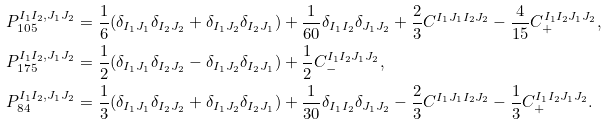<formula> <loc_0><loc_0><loc_500><loc_500>& P _ { 1 0 5 } ^ { I _ { 1 } I _ { 2 } , J _ { 1 } J _ { 2 } } = \frac { 1 } { 6 } ( \delta _ { I _ { 1 } J _ { 1 } } \delta _ { I _ { 2 } J _ { 2 } } + \delta _ { I _ { 1 } J _ { 2 } } \delta _ { I _ { 2 } J _ { 1 } } ) + \frac { 1 } { 6 0 } \delta _ { I _ { 1 } I _ { 2 } } \delta _ { J _ { 1 } J _ { 2 } } + \frac { 2 } { 3 } C ^ { I _ { 1 } J _ { 1 } I _ { 2 } J _ { 2 } } - \frac { 4 } { 1 5 } C _ { + } ^ { I _ { 1 } I _ { 2 } J _ { 1 } J _ { 2 } } , \\ & P _ { 1 7 5 } ^ { I _ { 1 } I _ { 2 } , J _ { 1 } J _ { 2 } } = \frac { 1 } { 2 } ( \delta _ { I _ { 1 } J _ { 1 } } \delta _ { I _ { 2 } J _ { 2 } } - \delta _ { I _ { 1 } J _ { 2 } } \delta _ { I _ { 2 } J _ { 1 } } ) + \frac { 1 } { 2 } C _ { - } ^ { I _ { 1 } I _ { 2 } J _ { 1 } J _ { 2 } } , \\ & P _ { 8 4 } ^ { I _ { 1 } I _ { 2 } , J _ { 1 } J _ { 2 } } = \frac { 1 } { 3 } ( \delta _ { I _ { 1 } J _ { 1 } } \delta _ { I _ { 2 } J _ { 2 } } + \delta _ { I _ { 1 } J _ { 2 } } \delta _ { I _ { 2 } J _ { 1 } } ) + \frac { 1 } { 3 0 } \delta _ { I _ { 1 } I _ { 2 } } \delta _ { J _ { 1 } J _ { 2 } } - \frac { 2 } { 3 } C ^ { I _ { 1 } J _ { 1 } I _ { 2 } J _ { 2 } } - \frac { 1 } { 3 } C _ { + } ^ { I _ { 1 } I _ { 2 } J _ { 1 } J _ { 2 } } .</formula> 